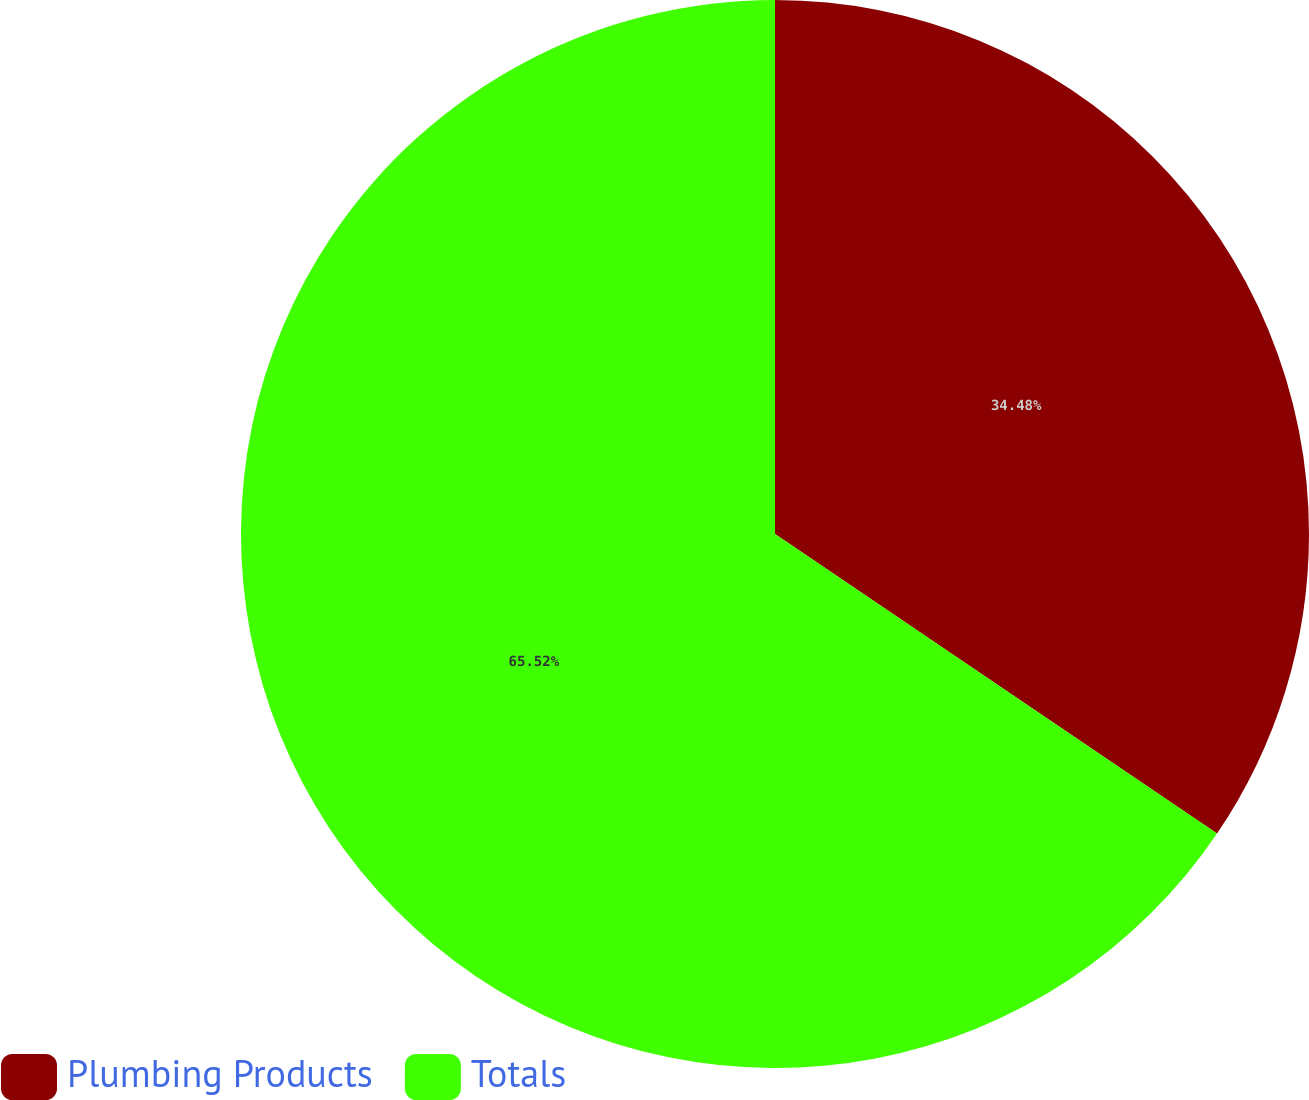Convert chart to OTSL. <chart><loc_0><loc_0><loc_500><loc_500><pie_chart><fcel>Plumbing Products<fcel>Totals<nl><fcel>34.48%<fcel>65.52%<nl></chart> 